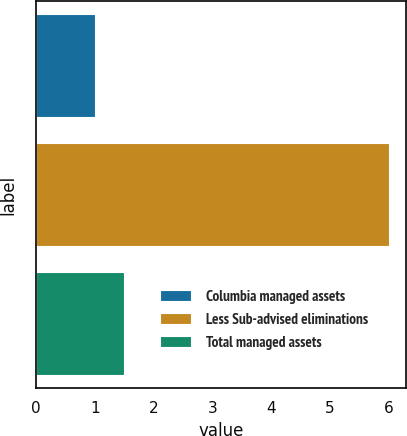<chart> <loc_0><loc_0><loc_500><loc_500><bar_chart><fcel>Columbia managed assets<fcel>Less Sub-advised eliminations<fcel>Total managed assets<nl><fcel>1<fcel>6<fcel>1.5<nl></chart> 